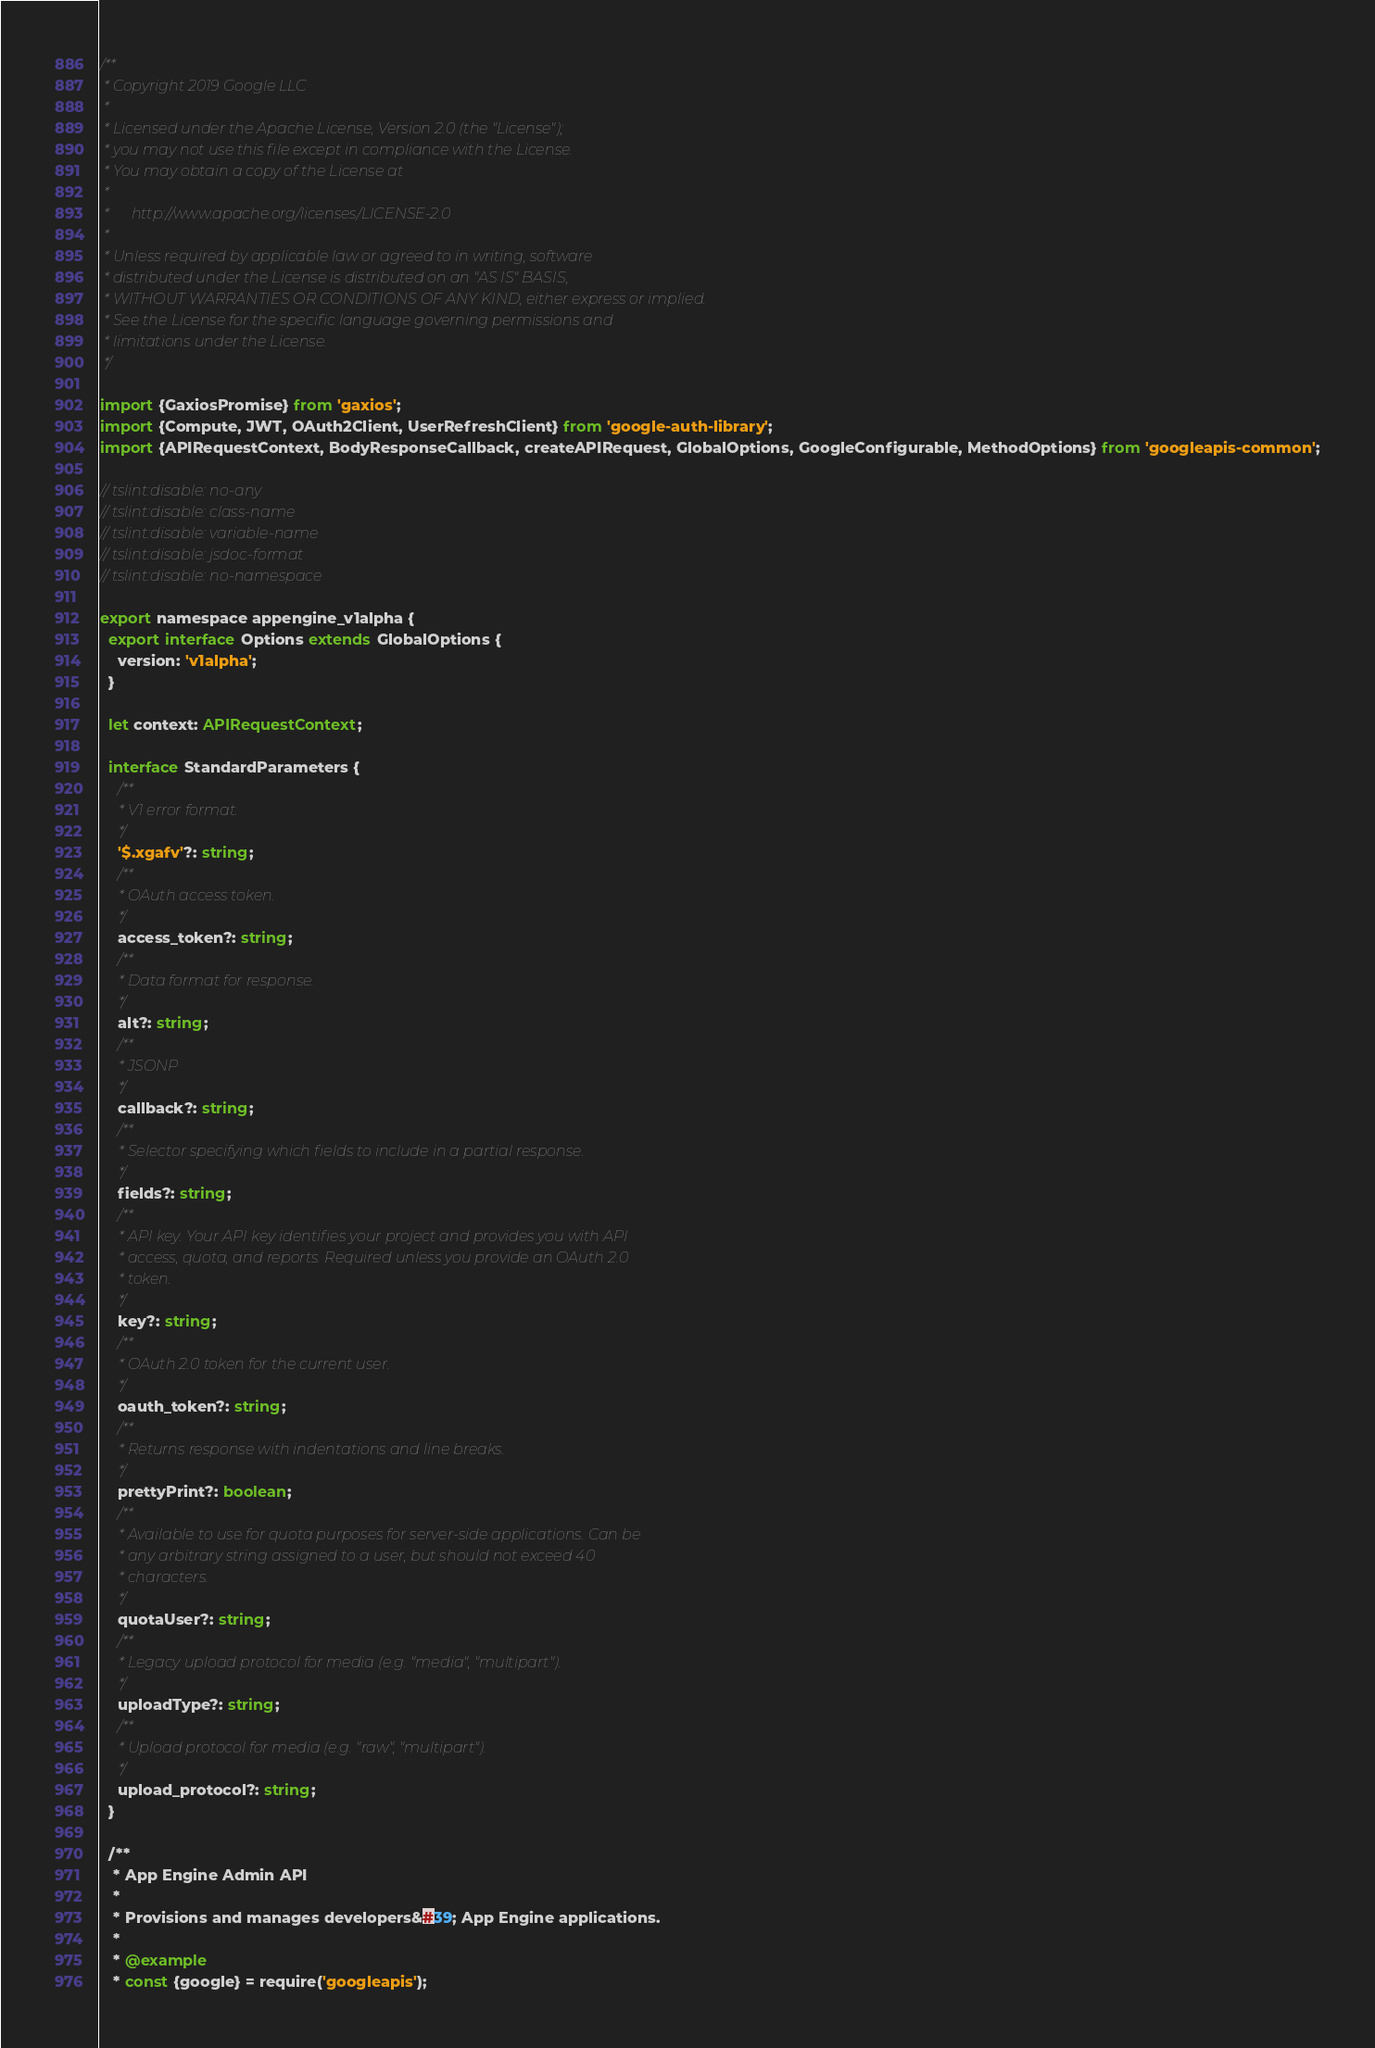Convert code to text. <code><loc_0><loc_0><loc_500><loc_500><_TypeScript_>/**
 * Copyright 2019 Google LLC
 *
 * Licensed under the Apache License, Version 2.0 (the "License");
 * you may not use this file except in compliance with the License.
 * You may obtain a copy of the License at
 *
 *      http://www.apache.org/licenses/LICENSE-2.0
 *
 * Unless required by applicable law or agreed to in writing, software
 * distributed under the License is distributed on an "AS IS" BASIS,
 * WITHOUT WARRANTIES OR CONDITIONS OF ANY KIND, either express or implied.
 * See the License for the specific language governing permissions and
 * limitations under the License.
 */

import {GaxiosPromise} from 'gaxios';
import {Compute, JWT, OAuth2Client, UserRefreshClient} from 'google-auth-library';
import {APIRequestContext, BodyResponseCallback, createAPIRequest, GlobalOptions, GoogleConfigurable, MethodOptions} from 'googleapis-common';

// tslint:disable: no-any
// tslint:disable: class-name
// tslint:disable: variable-name
// tslint:disable: jsdoc-format
// tslint:disable: no-namespace

export namespace appengine_v1alpha {
  export interface Options extends GlobalOptions {
    version: 'v1alpha';
  }

  let context: APIRequestContext;

  interface StandardParameters {
    /**
     * V1 error format.
     */
    '$.xgafv'?: string;
    /**
     * OAuth access token.
     */
    access_token?: string;
    /**
     * Data format for response.
     */
    alt?: string;
    /**
     * JSONP
     */
    callback?: string;
    /**
     * Selector specifying which fields to include in a partial response.
     */
    fields?: string;
    /**
     * API key. Your API key identifies your project and provides you with API
     * access, quota, and reports. Required unless you provide an OAuth 2.0
     * token.
     */
    key?: string;
    /**
     * OAuth 2.0 token for the current user.
     */
    oauth_token?: string;
    /**
     * Returns response with indentations and line breaks.
     */
    prettyPrint?: boolean;
    /**
     * Available to use for quota purposes for server-side applications. Can be
     * any arbitrary string assigned to a user, but should not exceed 40
     * characters.
     */
    quotaUser?: string;
    /**
     * Legacy upload protocol for media (e.g. "media", "multipart").
     */
    uploadType?: string;
    /**
     * Upload protocol for media (e.g. "raw", "multipart").
     */
    upload_protocol?: string;
  }

  /**
   * App Engine Admin API
   *
   * Provisions and manages developers&#39; App Engine applications.
   *
   * @example
   * const {google} = require('googleapis');</code> 